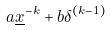Convert formula to latex. <formula><loc_0><loc_0><loc_500><loc_500>a \underline { x } ^ { - k } + b \delta ^ { ( k - 1 ) }</formula> 